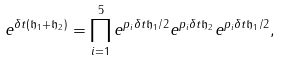Convert formula to latex. <formula><loc_0><loc_0><loc_500><loc_500>e ^ { \delta t ( \mathfrak h _ { 1 } + \mathfrak h _ { 2 } ) } = \prod _ { i = 1 } ^ { 5 } e ^ { p _ { i } \delta t \mathfrak h _ { 1 } / 2 } e ^ { p _ { i } \delta t \mathfrak h _ { 2 } } e ^ { p _ { i } \delta t \mathfrak h _ { 1 } / 2 } ,</formula> 